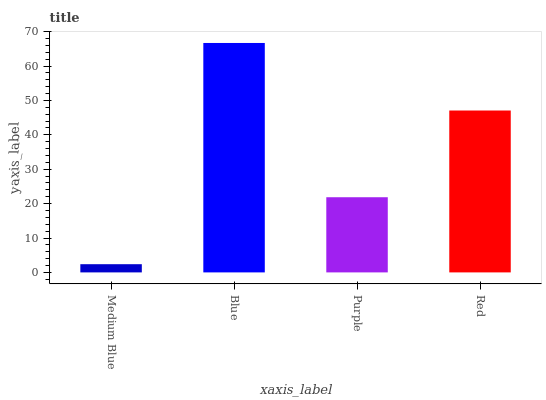Is Medium Blue the minimum?
Answer yes or no. Yes. Is Blue the maximum?
Answer yes or no. Yes. Is Purple the minimum?
Answer yes or no. No. Is Purple the maximum?
Answer yes or no. No. Is Blue greater than Purple?
Answer yes or no. Yes. Is Purple less than Blue?
Answer yes or no. Yes. Is Purple greater than Blue?
Answer yes or no. No. Is Blue less than Purple?
Answer yes or no. No. Is Red the high median?
Answer yes or no. Yes. Is Purple the low median?
Answer yes or no. Yes. Is Medium Blue the high median?
Answer yes or no. No. Is Medium Blue the low median?
Answer yes or no. No. 